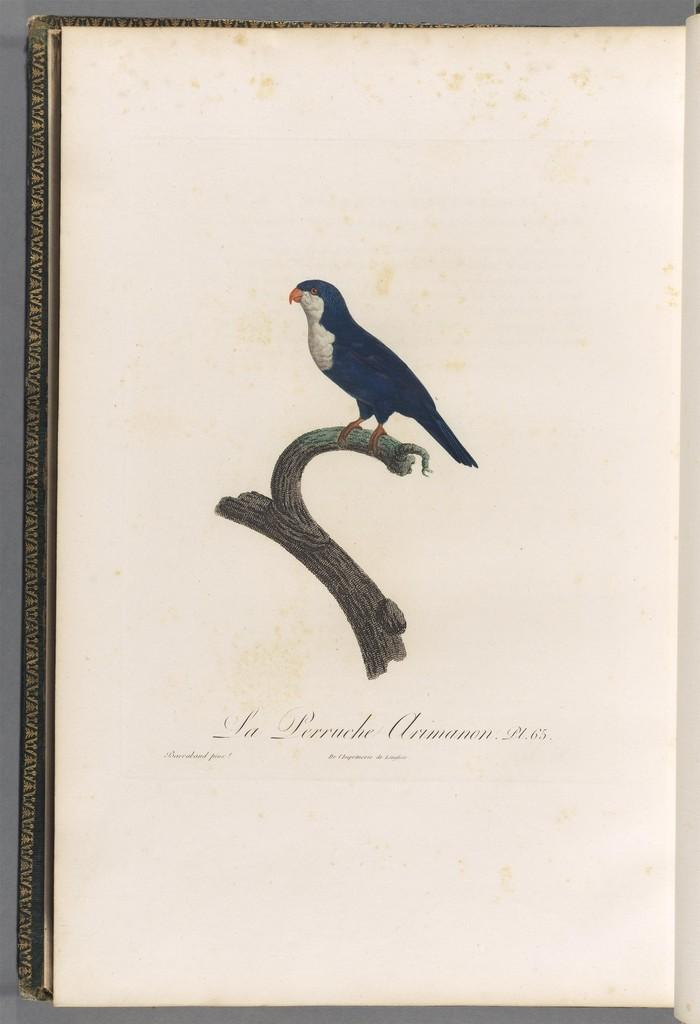What can be seen in the background of the image? There is a frame in the background of the image. What is on the frame? There is a paper on the frame. What is depicted on the paper? The paper contains an image of a bird and a branch of a tree. Are there any words on the paper? Yes, there is text on the paper. What type of skate is being used to prepare breakfast in the image? There is no skate or breakfast preparation visible in the image. 